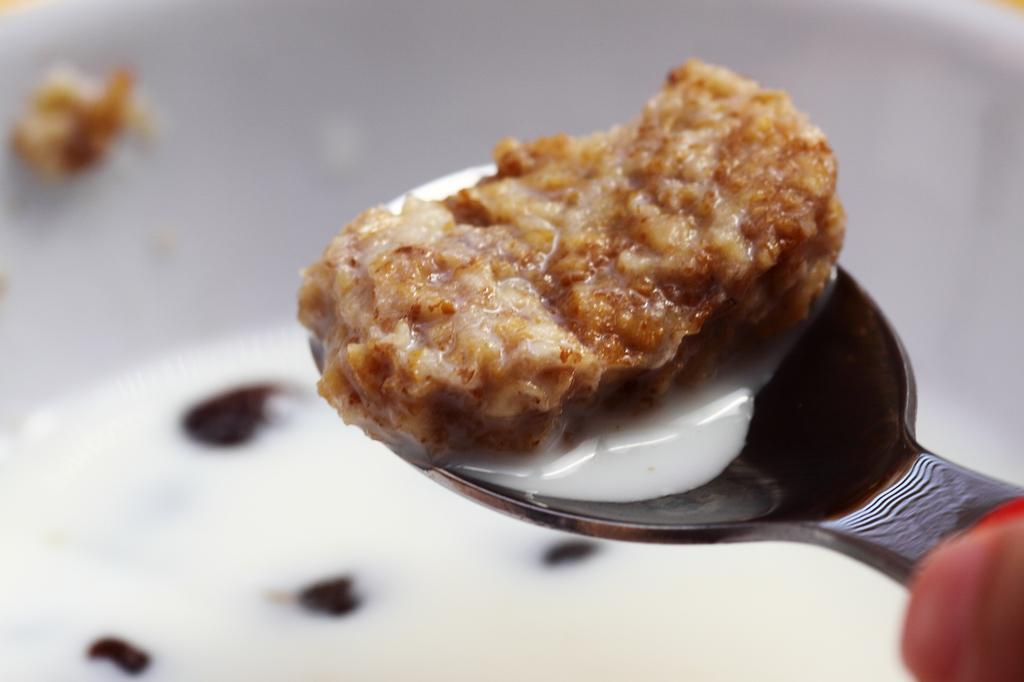What color is the bowl in the image? The bowl in the image is white colored. What color is the spoon in the image? The spoon in the image is silver colored. Who is holding the spoon in the image? A person is holding the spoon in the image. What type of food item is in the spoon? There is a brown colored food item in the spoon. What type of liquid is in the spoon? There is a white colored liquid in the spoon. How many pastes are visible in the image? There is no paste visible in the image. Are there any cobwebs present in the image? There is no mention of cobwebs in the provided facts, so we cannot determine if any are present in the image. 